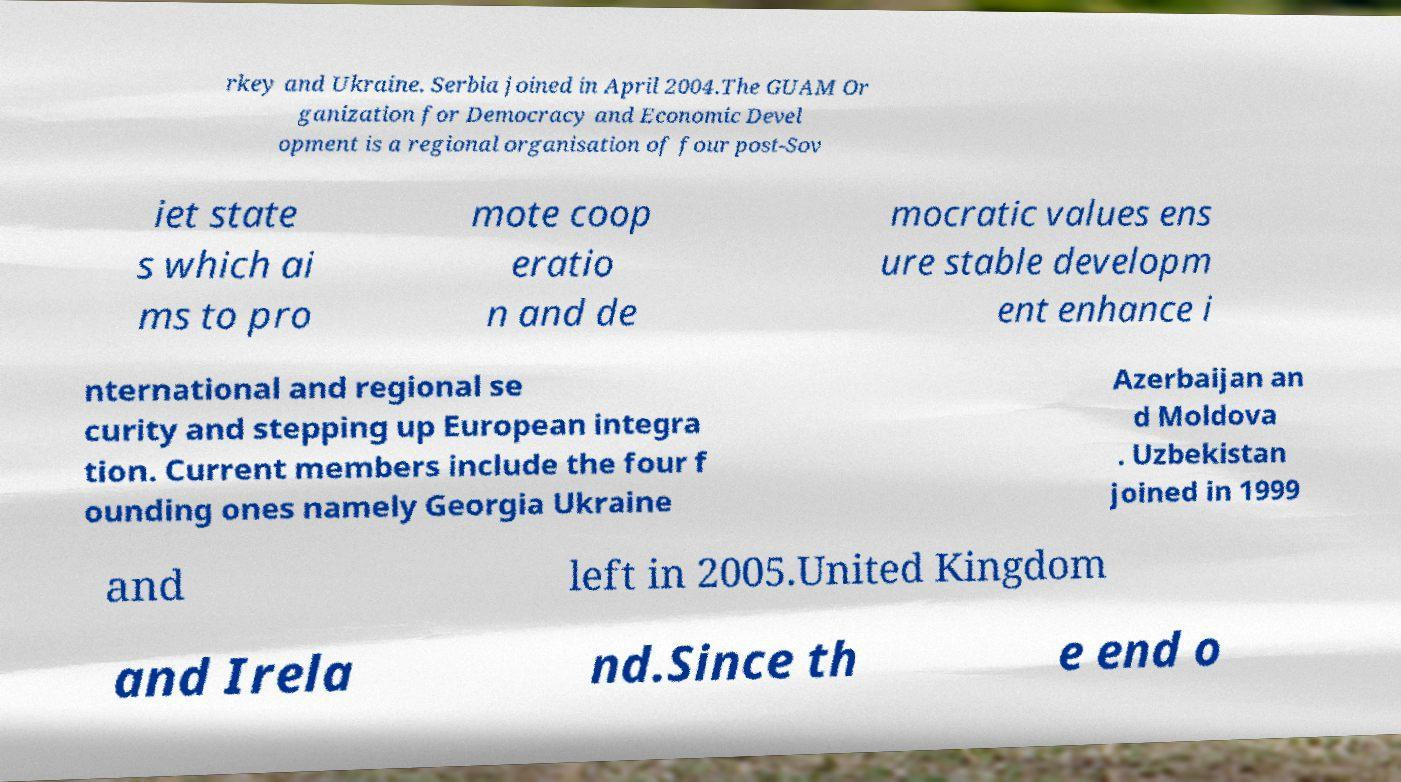Could you assist in decoding the text presented in this image and type it out clearly? rkey and Ukraine. Serbia joined in April 2004.The GUAM Or ganization for Democracy and Economic Devel opment is a regional organisation of four post-Sov iet state s which ai ms to pro mote coop eratio n and de mocratic values ens ure stable developm ent enhance i nternational and regional se curity and stepping up European integra tion. Current members include the four f ounding ones namely Georgia Ukraine Azerbaijan an d Moldova . Uzbekistan joined in 1999 and left in 2005.United Kingdom and Irela nd.Since th e end o 